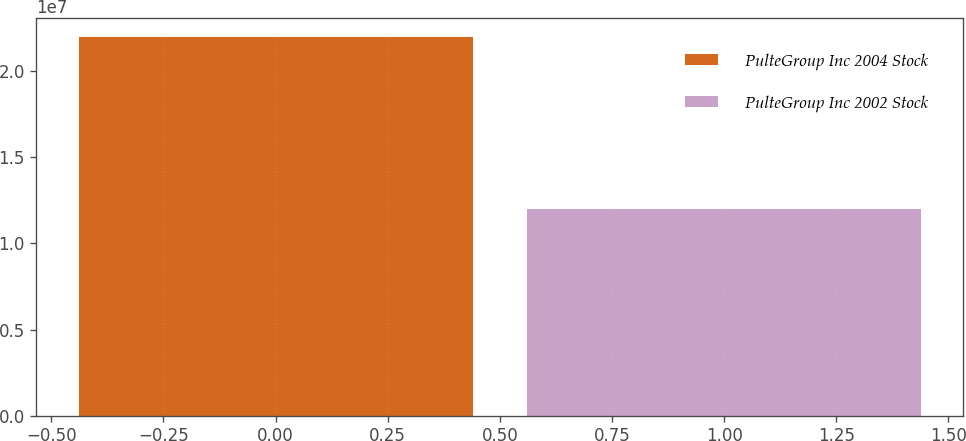Convert chart to OTSL. <chart><loc_0><loc_0><loc_500><loc_500><bar_chart><fcel>PulteGroup Inc 2004 Stock<fcel>PulteGroup Inc 2002 Stock<nl><fcel>2.2e+07<fcel>1.2e+07<nl></chart> 